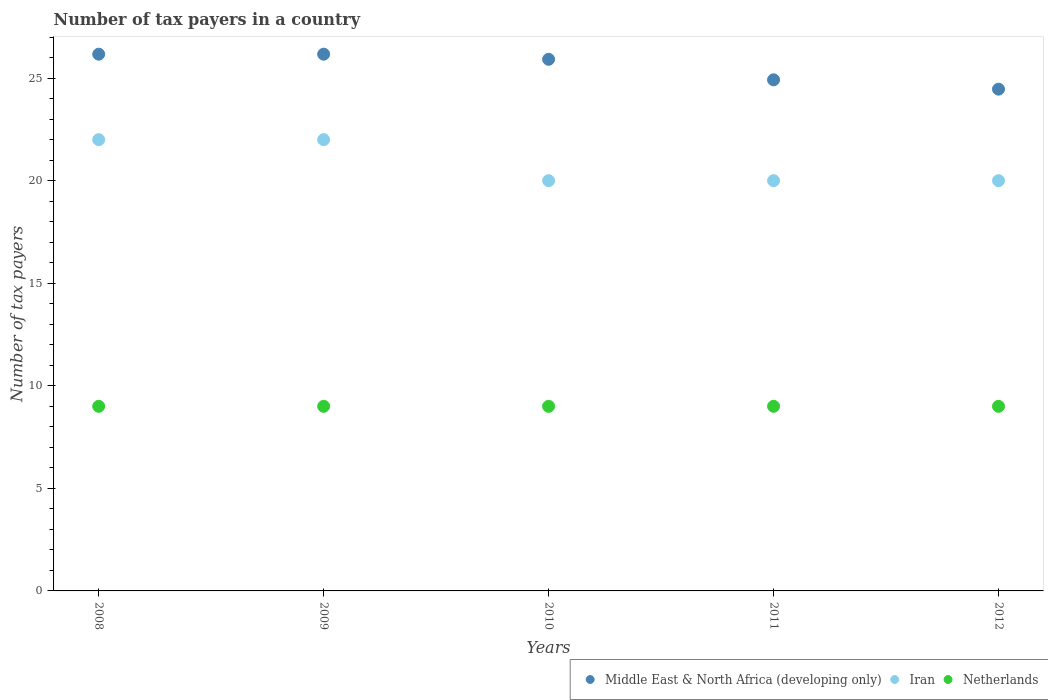Is the number of dotlines equal to the number of legend labels?
Keep it short and to the point. Yes. What is the number of tax payers in in Iran in 2010?
Your response must be concise. 20. Across all years, what is the maximum number of tax payers in in Netherlands?
Ensure brevity in your answer.  9. Across all years, what is the minimum number of tax payers in in Iran?
Your answer should be very brief. 20. In which year was the number of tax payers in in Iran maximum?
Your answer should be very brief. 2008. In which year was the number of tax payers in in Netherlands minimum?
Provide a succinct answer. 2008. What is the total number of tax payers in in Iran in the graph?
Your answer should be very brief. 104. What is the difference between the number of tax payers in in Middle East & North Africa (developing only) in 2008 and that in 2010?
Make the answer very short. 0.25. What is the difference between the number of tax payers in in Middle East & North Africa (developing only) in 2010 and the number of tax payers in in Netherlands in 2008?
Your answer should be very brief. 16.92. What is the average number of tax payers in in Iran per year?
Your response must be concise. 20.8. In the year 2012, what is the difference between the number of tax payers in in Iran and number of tax payers in in Netherlands?
Provide a succinct answer. 11. What is the ratio of the number of tax payers in in Iran in 2009 to that in 2010?
Make the answer very short. 1.1. Is the number of tax payers in in Middle East & North Africa (developing only) in 2011 less than that in 2012?
Make the answer very short. No. What is the difference between the highest and the lowest number of tax payers in in Netherlands?
Your answer should be compact. 0. In how many years, is the number of tax payers in in Iran greater than the average number of tax payers in in Iran taken over all years?
Offer a terse response. 2. Is the sum of the number of tax payers in in Iran in 2008 and 2011 greater than the maximum number of tax payers in in Netherlands across all years?
Your answer should be very brief. Yes. Is it the case that in every year, the sum of the number of tax payers in in Middle East & North Africa (developing only) and number of tax payers in in Netherlands  is greater than the number of tax payers in in Iran?
Make the answer very short. Yes. Is the number of tax payers in in Middle East & North Africa (developing only) strictly less than the number of tax payers in in Iran over the years?
Provide a short and direct response. No. What is the difference between two consecutive major ticks on the Y-axis?
Provide a short and direct response. 5. Does the graph contain any zero values?
Give a very brief answer. No. Does the graph contain grids?
Your response must be concise. No. Where does the legend appear in the graph?
Keep it short and to the point. Bottom right. What is the title of the graph?
Ensure brevity in your answer.  Number of tax payers in a country. Does "Latin America(all income levels)" appear as one of the legend labels in the graph?
Offer a terse response. No. What is the label or title of the Y-axis?
Offer a very short reply. Number of tax payers. What is the Number of tax payers of Middle East & North Africa (developing only) in 2008?
Your response must be concise. 26.17. What is the Number of tax payers in Middle East & North Africa (developing only) in 2009?
Offer a terse response. 26.17. What is the Number of tax payers in Netherlands in 2009?
Ensure brevity in your answer.  9. What is the Number of tax payers in Middle East & North Africa (developing only) in 2010?
Keep it short and to the point. 25.92. What is the Number of tax payers of Iran in 2010?
Make the answer very short. 20. What is the Number of tax payers of Middle East & North Africa (developing only) in 2011?
Your answer should be compact. 24.92. What is the Number of tax payers of Iran in 2011?
Your answer should be very brief. 20. What is the Number of tax payers in Middle East & North Africa (developing only) in 2012?
Offer a very short reply. 24.46. What is the Number of tax payers in Iran in 2012?
Offer a terse response. 20. What is the Number of tax payers in Netherlands in 2012?
Give a very brief answer. 9. Across all years, what is the maximum Number of tax payers of Middle East & North Africa (developing only)?
Offer a terse response. 26.17. Across all years, what is the maximum Number of tax payers of Netherlands?
Provide a succinct answer. 9. Across all years, what is the minimum Number of tax payers in Middle East & North Africa (developing only)?
Your answer should be compact. 24.46. Across all years, what is the minimum Number of tax payers of Netherlands?
Give a very brief answer. 9. What is the total Number of tax payers in Middle East & North Africa (developing only) in the graph?
Provide a short and direct response. 127.63. What is the total Number of tax payers of Iran in the graph?
Offer a very short reply. 104. What is the total Number of tax payers of Netherlands in the graph?
Keep it short and to the point. 45. What is the difference between the Number of tax payers in Middle East & North Africa (developing only) in 2008 and that in 2009?
Ensure brevity in your answer.  0. What is the difference between the Number of tax payers of Middle East & North Africa (developing only) in 2008 and that in 2010?
Keep it short and to the point. 0.25. What is the difference between the Number of tax payers of Iran in 2008 and that in 2010?
Provide a short and direct response. 2. What is the difference between the Number of tax payers in Middle East & North Africa (developing only) in 2008 and that in 2011?
Offer a very short reply. 1.25. What is the difference between the Number of tax payers in Iran in 2008 and that in 2011?
Offer a very short reply. 2. What is the difference between the Number of tax payers of Netherlands in 2008 and that in 2011?
Give a very brief answer. 0. What is the difference between the Number of tax payers in Middle East & North Africa (developing only) in 2008 and that in 2012?
Give a very brief answer. 1.71. What is the difference between the Number of tax payers of Iran in 2008 and that in 2012?
Offer a terse response. 2. What is the difference between the Number of tax payers of Middle East & North Africa (developing only) in 2009 and that in 2011?
Offer a terse response. 1.25. What is the difference between the Number of tax payers of Middle East & North Africa (developing only) in 2009 and that in 2012?
Your answer should be very brief. 1.71. What is the difference between the Number of tax payers in Middle East & North Africa (developing only) in 2010 and that in 2011?
Your answer should be very brief. 1. What is the difference between the Number of tax payers of Iran in 2010 and that in 2011?
Keep it short and to the point. 0. What is the difference between the Number of tax payers in Middle East & North Africa (developing only) in 2010 and that in 2012?
Your answer should be compact. 1.46. What is the difference between the Number of tax payers of Netherlands in 2010 and that in 2012?
Make the answer very short. 0. What is the difference between the Number of tax payers in Middle East & North Africa (developing only) in 2011 and that in 2012?
Your answer should be very brief. 0.46. What is the difference between the Number of tax payers of Iran in 2011 and that in 2012?
Offer a very short reply. 0. What is the difference between the Number of tax payers in Netherlands in 2011 and that in 2012?
Provide a short and direct response. 0. What is the difference between the Number of tax payers in Middle East & North Africa (developing only) in 2008 and the Number of tax payers in Iran in 2009?
Your response must be concise. 4.17. What is the difference between the Number of tax payers of Middle East & North Africa (developing only) in 2008 and the Number of tax payers of Netherlands in 2009?
Provide a short and direct response. 17.17. What is the difference between the Number of tax payers in Middle East & North Africa (developing only) in 2008 and the Number of tax payers in Iran in 2010?
Your answer should be compact. 6.17. What is the difference between the Number of tax payers in Middle East & North Africa (developing only) in 2008 and the Number of tax payers in Netherlands in 2010?
Provide a short and direct response. 17.17. What is the difference between the Number of tax payers in Middle East & North Africa (developing only) in 2008 and the Number of tax payers in Iran in 2011?
Offer a very short reply. 6.17. What is the difference between the Number of tax payers in Middle East & North Africa (developing only) in 2008 and the Number of tax payers in Netherlands in 2011?
Offer a very short reply. 17.17. What is the difference between the Number of tax payers in Iran in 2008 and the Number of tax payers in Netherlands in 2011?
Ensure brevity in your answer.  13. What is the difference between the Number of tax payers of Middle East & North Africa (developing only) in 2008 and the Number of tax payers of Iran in 2012?
Provide a succinct answer. 6.17. What is the difference between the Number of tax payers of Middle East & North Africa (developing only) in 2008 and the Number of tax payers of Netherlands in 2012?
Make the answer very short. 17.17. What is the difference between the Number of tax payers of Iran in 2008 and the Number of tax payers of Netherlands in 2012?
Provide a short and direct response. 13. What is the difference between the Number of tax payers of Middle East & North Africa (developing only) in 2009 and the Number of tax payers of Iran in 2010?
Offer a terse response. 6.17. What is the difference between the Number of tax payers in Middle East & North Africa (developing only) in 2009 and the Number of tax payers in Netherlands in 2010?
Your answer should be very brief. 17.17. What is the difference between the Number of tax payers of Middle East & North Africa (developing only) in 2009 and the Number of tax payers of Iran in 2011?
Provide a succinct answer. 6.17. What is the difference between the Number of tax payers of Middle East & North Africa (developing only) in 2009 and the Number of tax payers of Netherlands in 2011?
Make the answer very short. 17.17. What is the difference between the Number of tax payers in Iran in 2009 and the Number of tax payers in Netherlands in 2011?
Your answer should be compact. 13. What is the difference between the Number of tax payers in Middle East & North Africa (developing only) in 2009 and the Number of tax payers in Iran in 2012?
Give a very brief answer. 6.17. What is the difference between the Number of tax payers of Middle East & North Africa (developing only) in 2009 and the Number of tax payers of Netherlands in 2012?
Offer a very short reply. 17.17. What is the difference between the Number of tax payers in Middle East & North Africa (developing only) in 2010 and the Number of tax payers in Iran in 2011?
Your response must be concise. 5.92. What is the difference between the Number of tax payers in Middle East & North Africa (developing only) in 2010 and the Number of tax payers in Netherlands in 2011?
Keep it short and to the point. 16.92. What is the difference between the Number of tax payers of Middle East & North Africa (developing only) in 2010 and the Number of tax payers of Iran in 2012?
Offer a terse response. 5.92. What is the difference between the Number of tax payers in Middle East & North Africa (developing only) in 2010 and the Number of tax payers in Netherlands in 2012?
Your answer should be very brief. 16.92. What is the difference between the Number of tax payers of Iran in 2010 and the Number of tax payers of Netherlands in 2012?
Your answer should be compact. 11. What is the difference between the Number of tax payers in Middle East & North Africa (developing only) in 2011 and the Number of tax payers in Iran in 2012?
Provide a short and direct response. 4.92. What is the difference between the Number of tax payers of Middle East & North Africa (developing only) in 2011 and the Number of tax payers of Netherlands in 2012?
Ensure brevity in your answer.  15.92. What is the difference between the Number of tax payers of Iran in 2011 and the Number of tax payers of Netherlands in 2012?
Your response must be concise. 11. What is the average Number of tax payers of Middle East & North Africa (developing only) per year?
Provide a succinct answer. 25.53. What is the average Number of tax payers of Iran per year?
Provide a short and direct response. 20.8. In the year 2008, what is the difference between the Number of tax payers of Middle East & North Africa (developing only) and Number of tax payers of Iran?
Provide a short and direct response. 4.17. In the year 2008, what is the difference between the Number of tax payers of Middle East & North Africa (developing only) and Number of tax payers of Netherlands?
Your answer should be compact. 17.17. In the year 2009, what is the difference between the Number of tax payers in Middle East & North Africa (developing only) and Number of tax payers in Iran?
Offer a terse response. 4.17. In the year 2009, what is the difference between the Number of tax payers of Middle East & North Africa (developing only) and Number of tax payers of Netherlands?
Your answer should be compact. 17.17. In the year 2010, what is the difference between the Number of tax payers in Middle East & North Africa (developing only) and Number of tax payers in Iran?
Your answer should be very brief. 5.92. In the year 2010, what is the difference between the Number of tax payers in Middle East & North Africa (developing only) and Number of tax payers in Netherlands?
Keep it short and to the point. 16.92. In the year 2010, what is the difference between the Number of tax payers of Iran and Number of tax payers of Netherlands?
Give a very brief answer. 11. In the year 2011, what is the difference between the Number of tax payers of Middle East & North Africa (developing only) and Number of tax payers of Iran?
Provide a succinct answer. 4.92. In the year 2011, what is the difference between the Number of tax payers in Middle East & North Africa (developing only) and Number of tax payers in Netherlands?
Offer a very short reply. 15.92. In the year 2011, what is the difference between the Number of tax payers of Iran and Number of tax payers of Netherlands?
Ensure brevity in your answer.  11. In the year 2012, what is the difference between the Number of tax payers of Middle East & North Africa (developing only) and Number of tax payers of Iran?
Offer a very short reply. 4.46. In the year 2012, what is the difference between the Number of tax payers of Middle East & North Africa (developing only) and Number of tax payers of Netherlands?
Give a very brief answer. 15.46. What is the ratio of the Number of tax payers in Middle East & North Africa (developing only) in 2008 to that in 2009?
Your answer should be compact. 1. What is the ratio of the Number of tax payers of Netherlands in 2008 to that in 2009?
Your response must be concise. 1. What is the ratio of the Number of tax payers of Middle East & North Africa (developing only) in 2008 to that in 2010?
Offer a very short reply. 1.01. What is the ratio of the Number of tax payers of Middle East & North Africa (developing only) in 2008 to that in 2011?
Your answer should be very brief. 1.05. What is the ratio of the Number of tax payers of Iran in 2008 to that in 2011?
Keep it short and to the point. 1.1. What is the ratio of the Number of tax payers of Middle East & North Africa (developing only) in 2008 to that in 2012?
Offer a terse response. 1.07. What is the ratio of the Number of tax payers in Netherlands in 2008 to that in 2012?
Provide a succinct answer. 1. What is the ratio of the Number of tax payers of Middle East & North Africa (developing only) in 2009 to that in 2010?
Make the answer very short. 1.01. What is the ratio of the Number of tax payers of Iran in 2009 to that in 2010?
Give a very brief answer. 1.1. What is the ratio of the Number of tax payers in Middle East & North Africa (developing only) in 2009 to that in 2011?
Keep it short and to the point. 1.05. What is the ratio of the Number of tax payers in Netherlands in 2009 to that in 2011?
Make the answer very short. 1. What is the ratio of the Number of tax payers of Middle East & North Africa (developing only) in 2009 to that in 2012?
Your response must be concise. 1.07. What is the ratio of the Number of tax payers in Netherlands in 2009 to that in 2012?
Offer a very short reply. 1. What is the ratio of the Number of tax payers of Middle East & North Africa (developing only) in 2010 to that in 2011?
Offer a terse response. 1.04. What is the ratio of the Number of tax payers of Iran in 2010 to that in 2011?
Ensure brevity in your answer.  1. What is the ratio of the Number of tax payers of Middle East & North Africa (developing only) in 2010 to that in 2012?
Your answer should be compact. 1.06. What is the ratio of the Number of tax payers in Iran in 2010 to that in 2012?
Your answer should be compact. 1. What is the ratio of the Number of tax payers of Netherlands in 2010 to that in 2012?
Ensure brevity in your answer.  1. What is the ratio of the Number of tax payers in Middle East & North Africa (developing only) in 2011 to that in 2012?
Offer a very short reply. 1.02. What is the ratio of the Number of tax payers of Iran in 2011 to that in 2012?
Keep it short and to the point. 1. What is the ratio of the Number of tax payers of Netherlands in 2011 to that in 2012?
Provide a short and direct response. 1. What is the difference between the highest and the lowest Number of tax payers of Middle East & North Africa (developing only)?
Offer a very short reply. 1.71. What is the difference between the highest and the lowest Number of tax payers of Iran?
Ensure brevity in your answer.  2. What is the difference between the highest and the lowest Number of tax payers in Netherlands?
Provide a succinct answer. 0. 